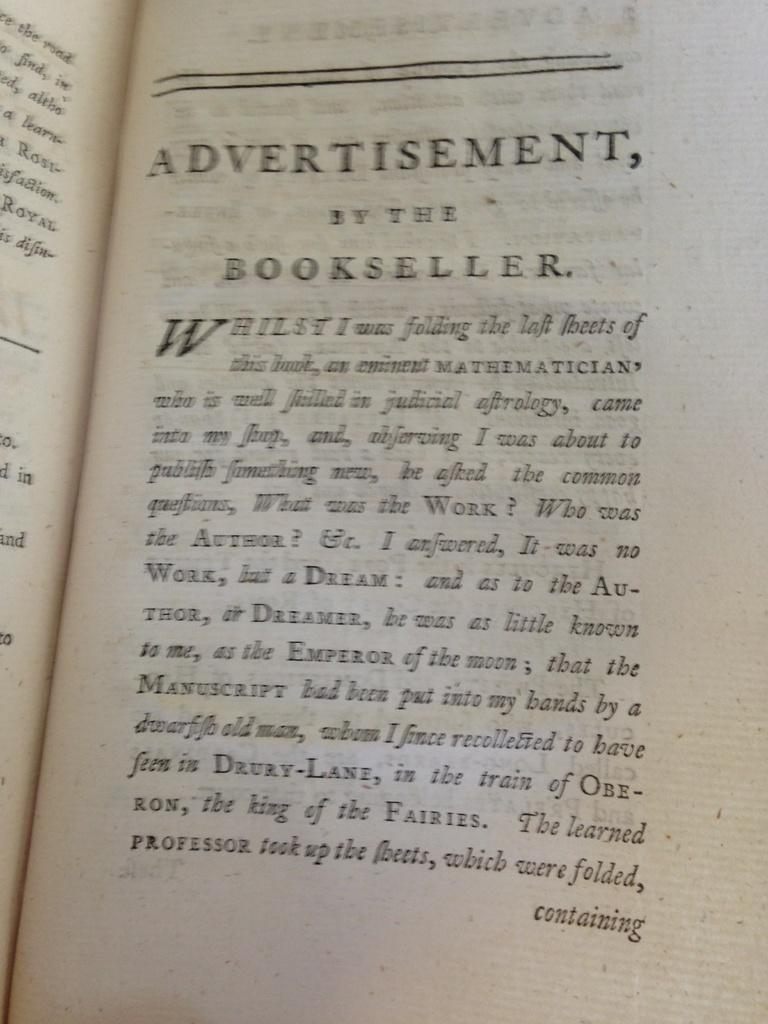Provide a one-sentence caption for the provided image. Page of a book with the title "Advertisement, By The Bookseller". 